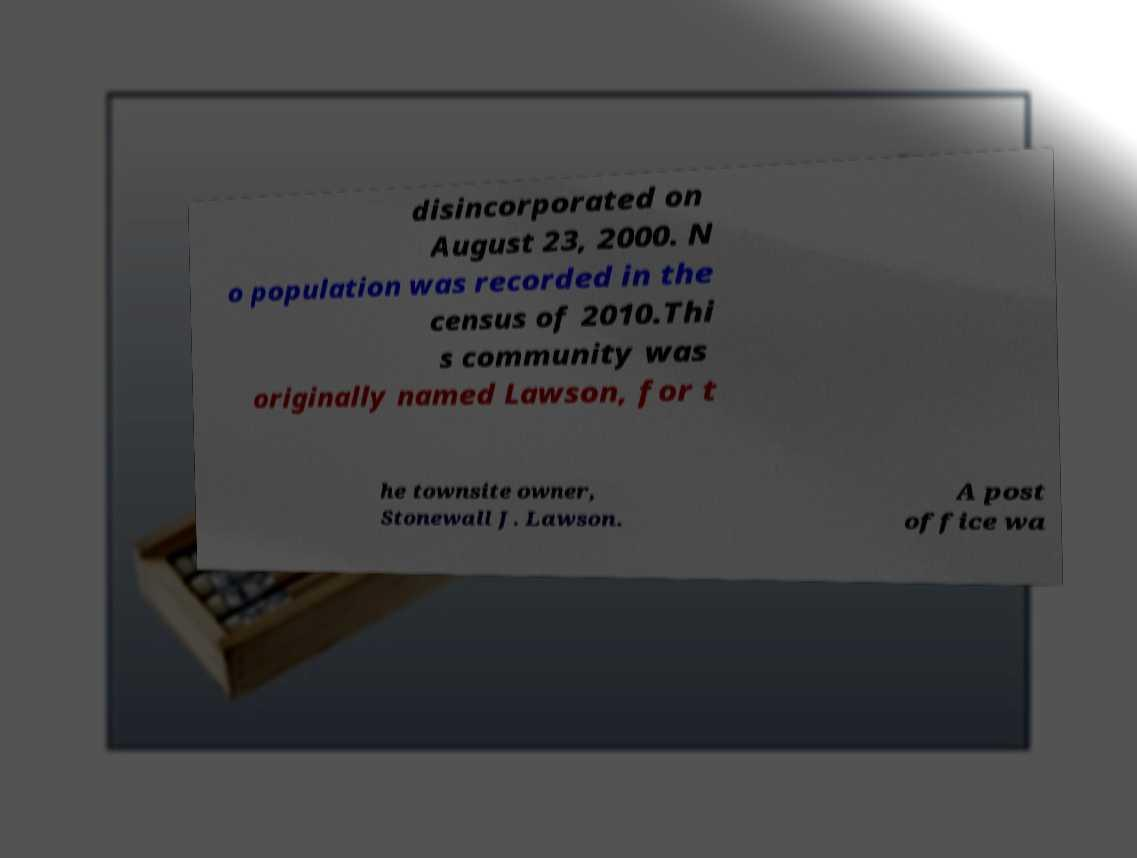Please identify and transcribe the text found in this image. disincorporated on August 23, 2000. N o population was recorded in the census of 2010.Thi s community was originally named Lawson, for t he townsite owner, Stonewall J. Lawson. A post office wa 